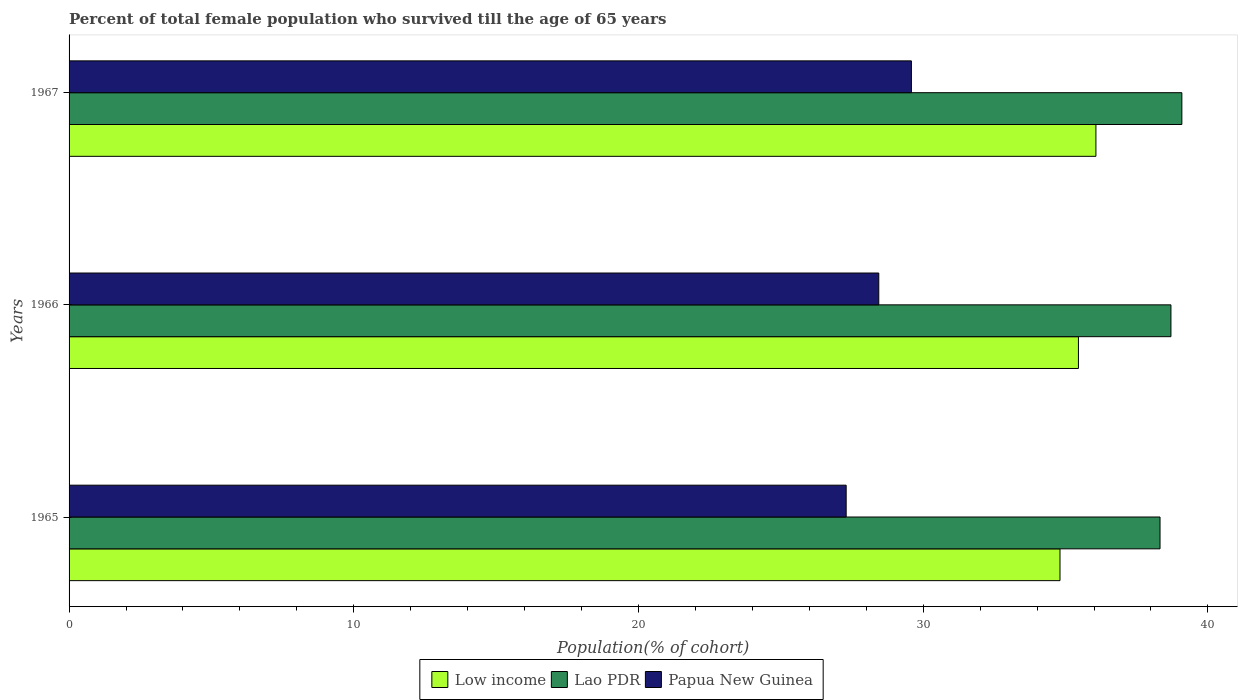How many different coloured bars are there?
Your answer should be compact. 3. How many groups of bars are there?
Offer a terse response. 3. Are the number of bars per tick equal to the number of legend labels?
Your answer should be compact. Yes. How many bars are there on the 1st tick from the bottom?
Your answer should be very brief. 3. What is the label of the 1st group of bars from the top?
Provide a short and direct response. 1967. What is the percentage of total female population who survived till the age of 65 years in Low income in 1965?
Your response must be concise. 34.8. Across all years, what is the maximum percentage of total female population who survived till the age of 65 years in Low income?
Your response must be concise. 36.07. Across all years, what is the minimum percentage of total female population who survived till the age of 65 years in Lao PDR?
Offer a terse response. 38.32. In which year was the percentage of total female population who survived till the age of 65 years in Low income maximum?
Make the answer very short. 1967. In which year was the percentage of total female population who survived till the age of 65 years in Papua New Guinea minimum?
Your answer should be compact. 1965. What is the total percentage of total female population who survived till the age of 65 years in Low income in the graph?
Offer a terse response. 106.32. What is the difference between the percentage of total female population who survived till the age of 65 years in Papua New Guinea in 1965 and that in 1967?
Offer a terse response. -2.29. What is the difference between the percentage of total female population who survived till the age of 65 years in Papua New Guinea in 1966 and the percentage of total female population who survived till the age of 65 years in Low income in 1965?
Give a very brief answer. -6.36. What is the average percentage of total female population who survived till the age of 65 years in Low income per year?
Your answer should be very brief. 35.44. In the year 1965, what is the difference between the percentage of total female population who survived till the age of 65 years in Papua New Guinea and percentage of total female population who survived till the age of 65 years in Low income?
Offer a very short reply. -7.51. What is the ratio of the percentage of total female population who survived till the age of 65 years in Papua New Guinea in 1965 to that in 1967?
Make the answer very short. 0.92. Is the percentage of total female population who survived till the age of 65 years in Low income in 1965 less than that in 1966?
Your answer should be very brief. Yes. What is the difference between the highest and the second highest percentage of total female population who survived till the age of 65 years in Papua New Guinea?
Offer a terse response. 1.15. What is the difference between the highest and the lowest percentage of total female population who survived till the age of 65 years in Lao PDR?
Provide a short and direct response. 0.77. What does the 3rd bar from the top in 1967 represents?
Offer a very short reply. Low income. What does the 2nd bar from the bottom in 1967 represents?
Keep it short and to the point. Lao PDR. Does the graph contain any zero values?
Your response must be concise. No. Does the graph contain grids?
Provide a short and direct response. No. How many legend labels are there?
Make the answer very short. 3. What is the title of the graph?
Ensure brevity in your answer.  Percent of total female population who survived till the age of 65 years. Does "Mozambique" appear as one of the legend labels in the graph?
Provide a succinct answer. No. What is the label or title of the X-axis?
Make the answer very short. Population(% of cohort). What is the Population(% of cohort) of Low income in 1965?
Provide a succinct answer. 34.8. What is the Population(% of cohort) of Lao PDR in 1965?
Make the answer very short. 38.32. What is the Population(% of cohort) of Papua New Guinea in 1965?
Keep it short and to the point. 27.29. What is the Population(% of cohort) of Low income in 1966?
Provide a succinct answer. 35.45. What is the Population(% of cohort) in Lao PDR in 1966?
Your answer should be very brief. 38.7. What is the Population(% of cohort) in Papua New Guinea in 1966?
Make the answer very short. 28.44. What is the Population(% of cohort) of Low income in 1967?
Ensure brevity in your answer.  36.07. What is the Population(% of cohort) of Lao PDR in 1967?
Offer a very short reply. 39.08. What is the Population(% of cohort) of Papua New Guinea in 1967?
Make the answer very short. 29.59. Across all years, what is the maximum Population(% of cohort) in Low income?
Ensure brevity in your answer.  36.07. Across all years, what is the maximum Population(% of cohort) of Lao PDR?
Your response must be concise. 39.08. Across all years, what is the maximum Population(% of cohort) of Papua New Guinea?
Offer a terse response. 29.59. Across all years, what is the minimum Population(% of cohort) in Low income?
Ensure brevity in your answer.  34.8. Across all years, what is the minimum Population(% of cohort) in Lao PDR?
Provide a short and direct response. 38.32. Across all years, what is the minimum Population(% of cohort) of Papua New Guinea?
Give a very brief answer. 27.29. What is the total Population(% of cohort) of Low income in the graph?
Provide a short and direct response. 106.32. What is the total Population(% of cohort) in Lao PDR in the graph?
Keep it short and to the point. 116.1. What is the total Population(% of cohort) of Papua New Guinea in the graph?
Ensure brevity in your answer.  85.32. What is the difference between the Population(% of cohort) in Low income in 1965 and that in 1966?
Your answer should be compact. -0.65. What is the difference between the Population(% of cohort) in Lao PDR in 1965 and that in 1966?
Offer a terse response. -0.38. What is the difference between the Population(% of cohort) in Papua New Guinea in 1965 and that in 1966?
Offer a terse response. -1.15. What is the difference between the Population(% of cohort) in Low income in 1965 and that in 1967?
Your answer should be very brief. -1.26. What is the difference between the Population(% of cohort) in Lao PDR in 1965 and that in 1967?
Give a very brief answer. -0.77. What is the difference between the Population(% of cohort) in Papua New Guinea in 1965 and that in 1967?
Offer a very short reply. -2.29. What is the difference between the Population(% of cohort) of Low income in 1966 and that in 1967?
Ensure brevity in your answer.  -0.61. What is the difference between the Population(% of cohort) of Lao PDR in 1966 and that in 1967?
Your answer should be compact. -0.38. What is the difference between the Population(% of cohort) of Papua New Guinea in 1966 and that in 1967?
Your answer should be very brief. -1.15. What is the difference between the Population(% of cohort) of Low income in 1965 and the Population(% of cohort) of Lao PDR in 1966?
Offer a terse response. -3.9. What is the difference between the Population(% of cohort) of Low income in 1965 and the Population(% of cohort) of Papua New Guinea in 1966?
Your response must be concise. 6.36. What is the difference between the Population(% of cohort) of Lao PDR in 1965 and the Population(% of cohort) of Papua New Guinea in 1966?
Keep it short and to the point. 9.88. What is the difference between the Population(% of cohort) in Low income in 1965 and the Population(% of cohort) in Lao PDR in 1967?
Offer a terse response. -4.28. What is the difference between the Population(% of cohort) of Low income in 1965 and the Population(% of cohort) of Papua New Guinea in 1967?
Provide a short and direct response. 5.22. What is the difference between the Population(% of cohort) of Lao PDR in 1965 and the Population(% of cohort) of Papua New Guinea in 1967?
Offer a very short reply. 8.73. What is the difference between the Population(% of cohort) of Low income in 1966 and the Population(% of cohort) of Lao PDR in 1967?
Give a very brief answer. -3.63. What is the difference between the Population(% of cohort) in Low income in 1966 and the Population(% of cohort) in Papua New Guinea in 1967?
Provide a succinct answer. 5.87. What is the difference between the Population(% of cohort) of Lao PDR in 1966 and the Population(% of cohort) of Papua New Guinea in 1967?
Keep it short and to the point. 9.12. What is the average Population(% of cohort) of Low income per year?
Give a very brief answer. 35.44. What is the average Population(% of cohort) in Lao PDR per year?
Your response must be concise. 38.7. What is the average Population(% of cohort) in Papua New Guinea per year?
Provide a short and direct response. 28.44. In the year 1965, what is the difference between the Population(% of cohort) in Low income and Population(% of cohort) in Lao PDR?
Make the answer very short. -3.51. In the year 1965, what is the difference between the Population(% of cohort) of Low income and Population(% of cohort) of Papua New Guinea?
Your response must be concise. 7.51. In the year 1965, what is the difference between the Population(% of cohort) of Lao PDR and Population(% of cohort) of Papua New Guinea?
Your answer should be very brief. 11.02. In the year 1966, what is the difference between the Population(% of cohort) of Low income and Population(% of cohort) of Lao PDR?
Your answer should be compact. -3.25. In the year 1966, what is the difference between the Population(% of cohort) in Low income and Population(% of cohort) in Papua New Guinea?
Offer a terse response. 7.01. In the year 1966, what is the difference between the Population(% of cohort) of Lao PDR and Population(% of cohort) of Papua New Guinea?
Provide a succinct answer. 10.26. In the year 1967, what is the difference between the Population(% of cohort) in Low income and Population(% of cohort) in Lao PDR?
Your response must be concise. -3.02. In the year 1967, what is the difference between the Population(% of cohort) of Low income and Population(% of cohort) of Papua New Guinea?
Your response must be concise. 6.48. In the year 1967, what is the difference between the Population(% of cohort) in Lao PDR and Population(% of cohort) in Papua New Guinea?
Provide a short and direct response. 9.5. What is the ratio of the Population(% of cohort) in Low income in 1965 to that in 1966?
Provide a short and direct response. 0.98. What is the ratio of the Population(% of cohort) in Lao PDR in 1965 to that in 1966?
Offer a very short reply. 0.99. What is the ratio of the Population(% of cohort) in Papua New Guinea in 1965 to that in 1966?
Keep it short and to the point. 0.96. What is the ratio of the Population(% of cohort) of Lao PDR in 1965 to that in 1967?
Offer a very short reply. 0.98. What is the ratio of the Population(% of cohort) in Papua New Guinea in 1965 to that in 1967?
Offer a very short reply. 0.92. What is the ratio of the Population(% of cohort) of Low income in 1966 to that in 1967?
Provide a succinct answer. 0.98. What is the ratio of the Population(% of cohort) in Lao PDR in 1966 to that in 1967?
Make the answer very short. 0.99. What is the ratio of the Population(% of cohort) in Papua New Guinea in 1966 to that in 1967?
Your answer should be very brief. 0.96. What is the difference between the highest and the second highest Population(% of cohort) of Low income?
Make the answer very short. 0.61. What is the difference between the highest and the second highest Population(% of cohort) of Lao PDR?
Provide a succinct answer. 0.38. What is the difference between the highest and the second highest Population(% of cohort) of Papua New Guinea?
Your answer should be compact. 1.15. What is the difference between the highest and the lowest Population(% of cohort) of Low income?
Your response must be concise. 1.26. What is the difference between the highest and the lowest Population(% of cohort) in Lao PDR?
Offer a very short reply. 0.77. What is the difference between the highest and the lowest Population(% of cohort) of Papua New Guinea?
Your response must be concise. 2.29. 